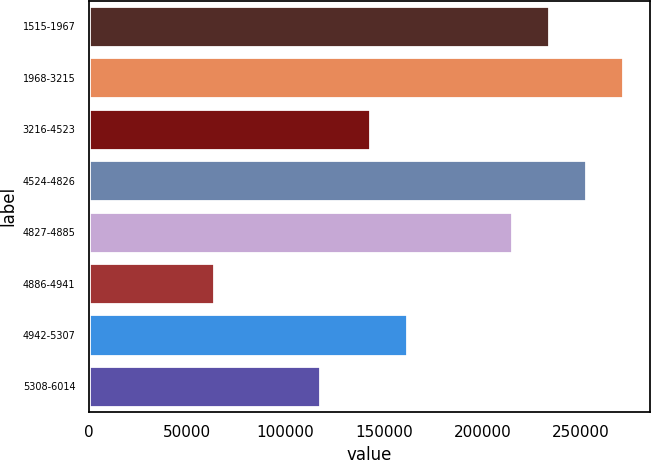Convert chart to OTSL. <chart><loc_0><loc_0><loc_500><loc_500><bar_chart><fcel>1515-1967<fcel>1968-3215<fcel>3216-4523<fcel>4524-4826<fcel>4827-4885<fcel>4886-4941<fcel>4942-5307<fcel>5308-6014<nl><fcel>233926<fcel>271313<fcel>142986<fcel>252620<fcel>215232<fcel>63561<fcel>161680<fcel>117403<nl></chart> 